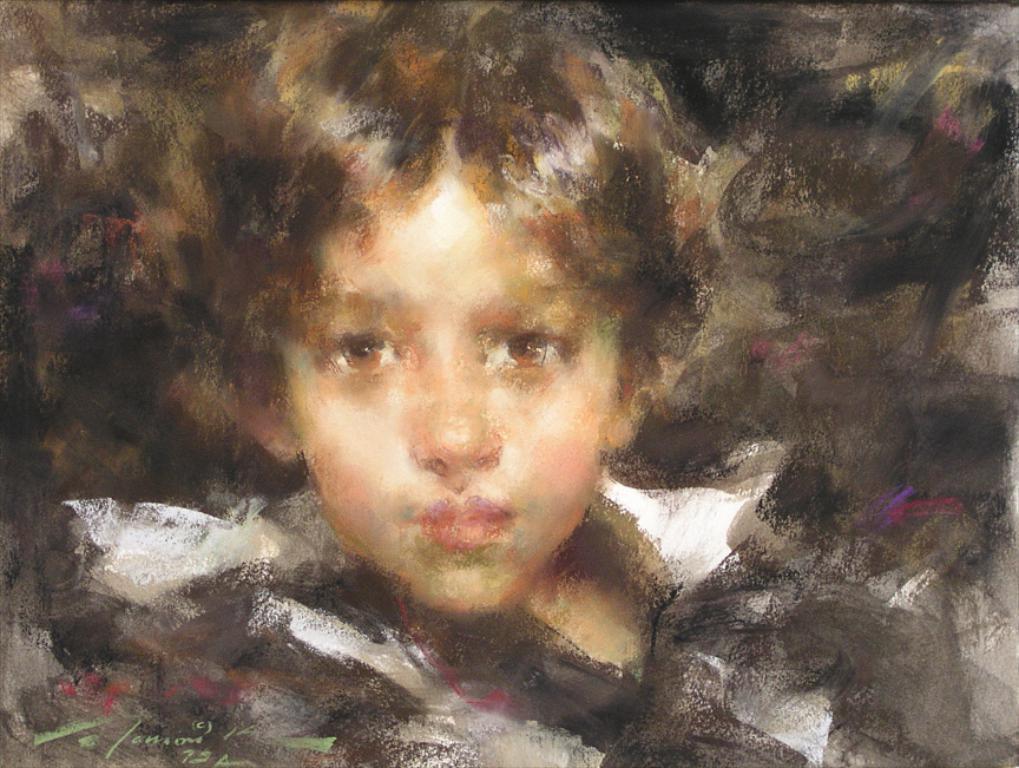Could you give a brief overview of what you see in this image? This is a painted picture of a person. 